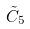<formula> <loc_0><loc_0><loc_500><loc_500>\tilde { C } _ { 5 }</formula> 